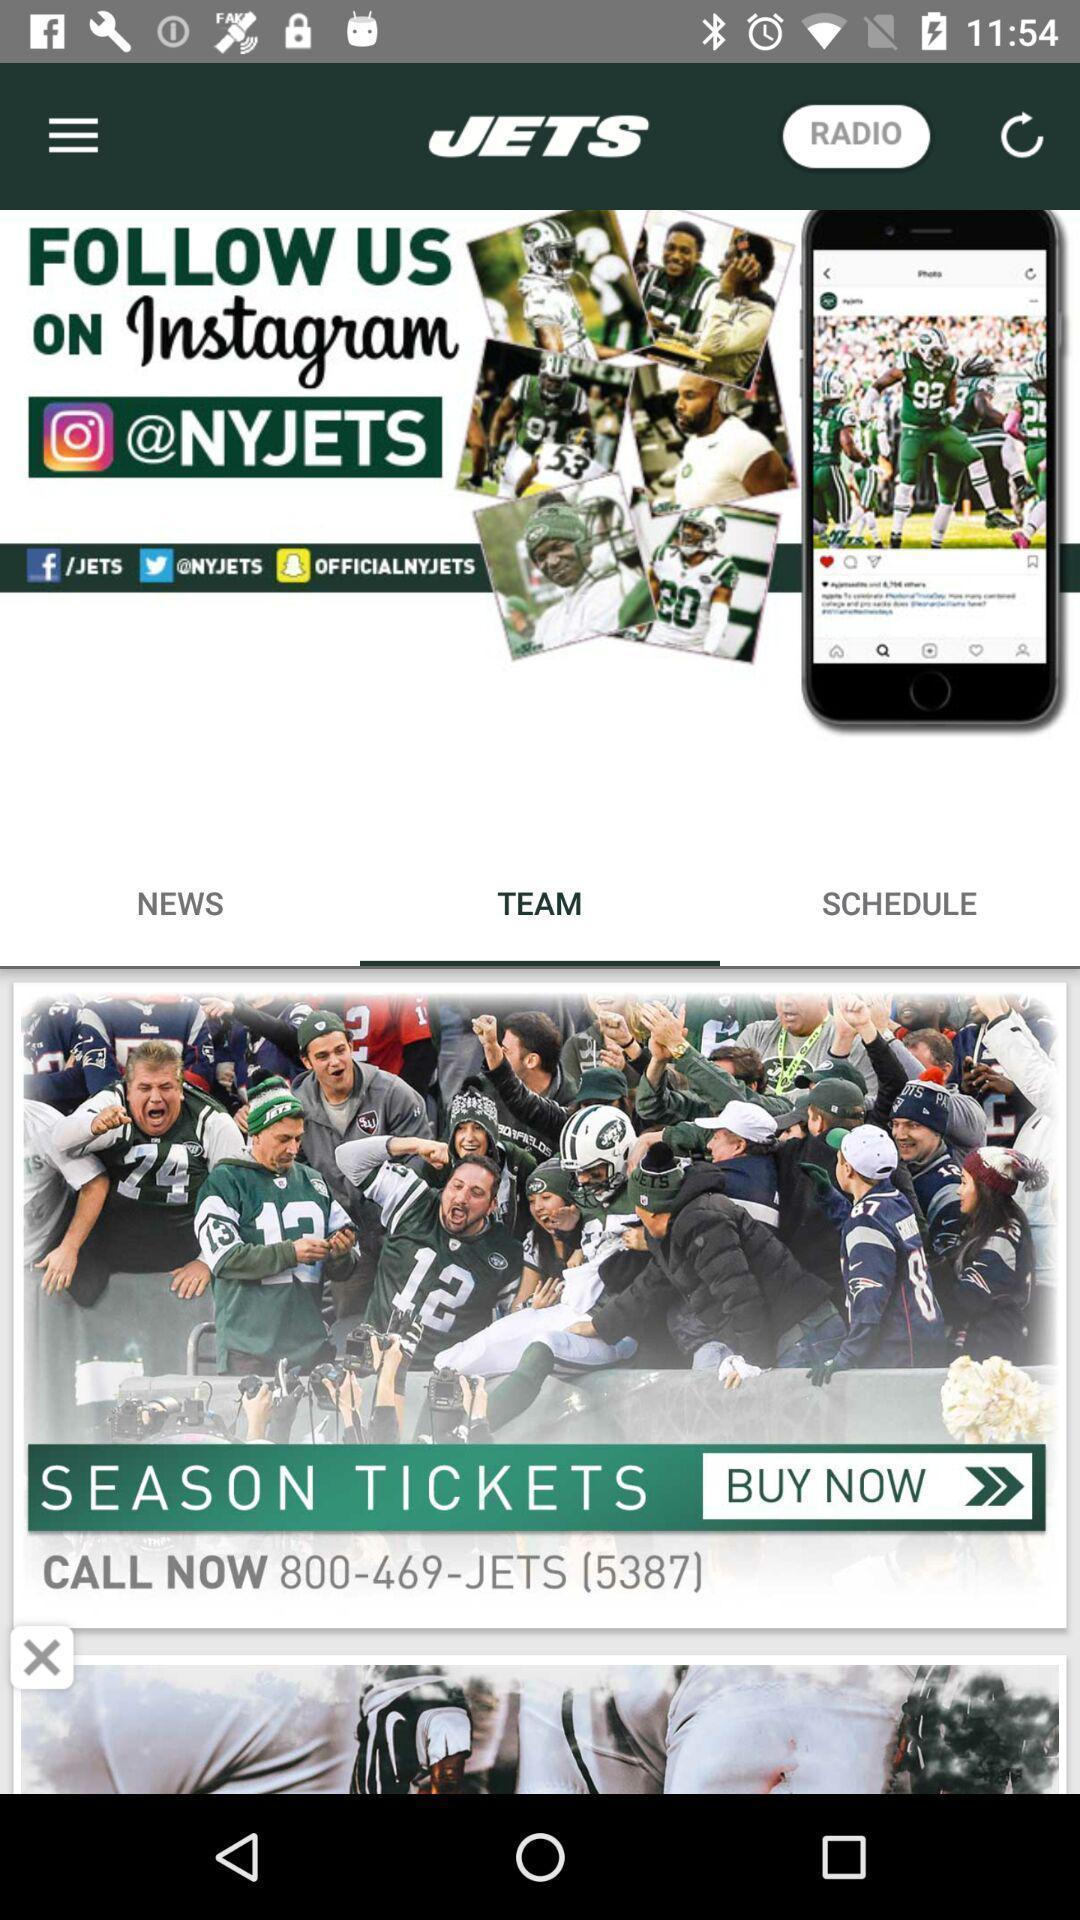Provide a detailed account of this screenshot. Screen displaying information in a gaming application. 